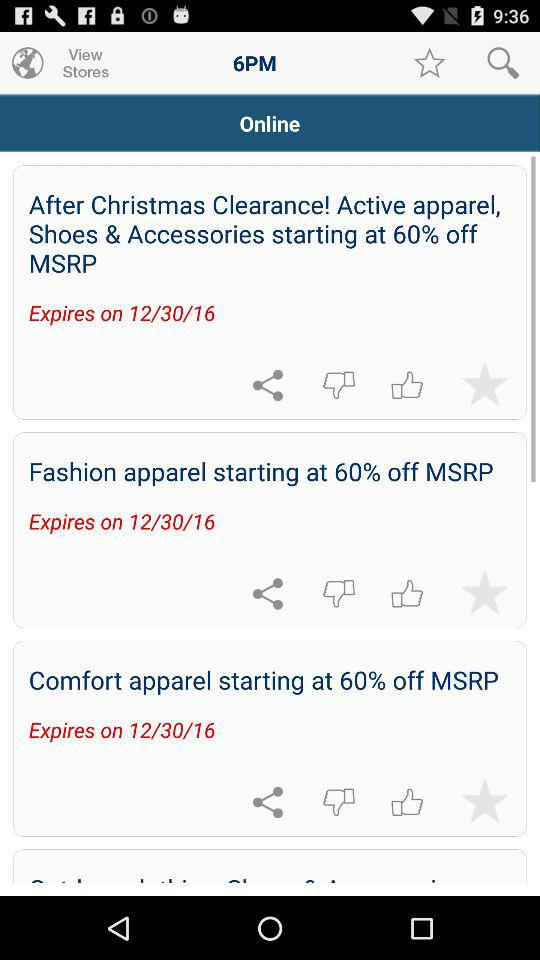How many login options are there that use an email address?
Answer the question using a single word or phrase. 2 